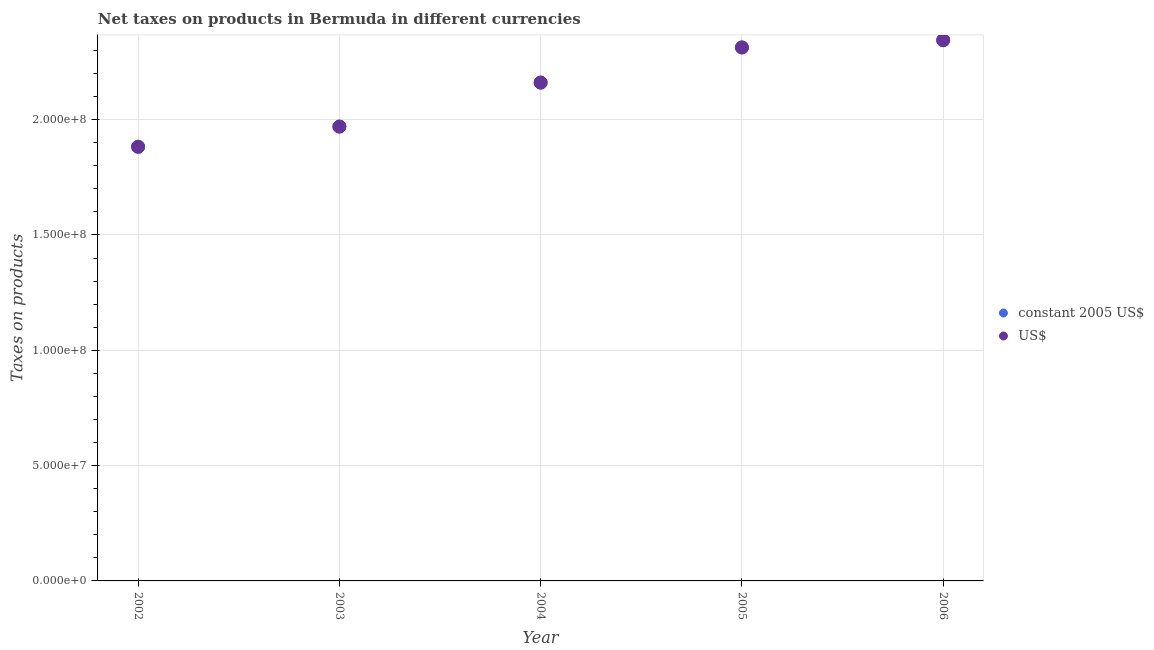What is the net taxes in us$ in 2005?
Your answer should be compact. 2.31e+08. Across all years, what is the maximum net taxes in us$?
Your response must be concise. 2.34e+08. Across all years, what is the minimum net taxes in us$?
Offer a very short reply. 1.88e+08. In which year was the net taxes in us$ maximum?
Provide a short and direct response. 2006. In which year was the net taxes in us$ minimum?
Offer a terse response. 2002. What is the total net taxes in constant 2005 us$ in the graph?
Keep it short and to the point. 1.07e+09. What is the difference between the net taxes in constant 2005 us$ in 2004 and that in 2006?
Keep it short and to the point. -1.84e+07. What is the difference between the net taxes in us$ in 2006 and the net taxes in constant 2005 us$ in 2005?
Make the answer very short. 3.14e+06. What is the average net taxes in us$ per year?
Provide a short and direct response. 2.13e+08. In the year 2005, what is the difference between the net taxes in constant 2005 us$ and net taxes in us$?
Provide a succinct answer. 0. In how many years, is the net taxes in us$ greater than 90000000 units?
Your answer should be compact. 5. What is the ratio of the net taxes in constant 2005 us$ in 2002 to that in 2006?
Keep it short and to the point. 0.8. Is the difference between the net taxes in constant 2005 us$ in 2005 and 2006 greater than the difference between the net taxes in us$ in 2005 and 2006?
Offer a terse response. No. What is the difference between the highest and the second highest net taxes in constant 2005 us$?
Give a very brief answer. 3.14e+06. What is the difference between the highest and the lowest net taxes in constant 2005 us$?
Keep it short and to the point. 4.62e+07. Is the sum of the net taxes in us$ in 2003 and 2006 greater than the maximum net taxes in constant 2005 us$ across all years?
Offer a very short reply. Yes. Does the net taxes in constant 2005 us$ monotonically increase over the years?
Your response must be concise. Yes. Is the net taxes in us$ strictly greater than the net taxes in constant 2005 us$ over the years?
Provide a succinct answer. No. Is the net taxes in us$ strictly less than the net taxes in constant 2005 us$ over the years?
Offer a very short reply. No. Does the graph contain any zero values?
Your answer should be compact. No. What is the title of the graph?
Make the answer very short. Net taxes on products in Bermuda in different currencies. What is the label or title of the Y-axis?
Your answer should be compact. Taxes on products. What is the Taxes on products in constant 2005 US$ in 2002?
Ensure brevity in your answer.  1.88e+08. What is the Taxes on products in US$ in 2002?
Ensure brevity in your answer.  1.88e+08. What is the Taxes on products of constant 2005 US$ in 2003?
Keep it short and to the point. 1.97e+08. What is the Taxes on products of US$ in 2003?
Your response must be concise. 1.97e+08. What is the Taxes on products of constant 2005 US$ in 2004?
Your answer should be compact. 2.16e+08. What is the Taxes on products of US$ in 2004?
Your answer should be compact. 2.16e+08. What is the Taxes on products of constant 2005 US$ in 2005?
Your response must be concise. 2.31e+08. What is the Taxes on products of US$ in 2005?
Give a very brief answer. 2.31e+08. What is the Taxes on products of constant 2005 US$ in 2006?
Ensure brevity in your answer.  2.34e+08. What is the Taxes on products in US$ in 2006?
Keep it short and to the point. 2.34e+08. Across all years, what is the maximum Taxes on products of constant 2005 US$?
Ensure brevity in your answer.  2.34e+08. Across all years, what is the maximum Taxes on products of US$?
Provide a short and direct response. 2.34e+08. Across all years, what is the minimum Taxes on products in constant 2005 US$?
Your response must be concise. 1.88e+08. Across all years, what is the minimum Taxes on products of US$?
Your response must be concise. 1.88e+08. What is the total Taxes on products of constant 2005 US$ in the graph?
Provide a short and direct response. 1.07e+09. What is the total Taxes on products of US$ in the graph?
Your answer should be compact. 1.07e+09. What is the difference between the Taxes on products of constant 2005 US$ in 2002 and that in 2003?
Give a very brief answer. -8.75e+06. What is the difference between the Taxes on products in US$ in 2002 and that in 2003?
Offer a terse response. -8.75e+06. What is the difference between the Taxes on products in constant 2005 US$ in 2002 and that in 2004?
Provide a short and direct response. -2.78e+07. What is the difference between the Taxes on products in US$ in 2002 and that in 2004?
Offer a very short reply. -2.78e+07. What is the difference between the Taxes on products in constant 2005 US$ in 2002 and that in 2005?
Offer a very short reply. -4.31e+07. What is the difference between the Taxes on products in US$ in 2002 and that in 2005?
Keep it short and to the point. -4.31e+07. What is the difference between the Taxes on products in constant 2005 US$ in 2002 and that in 2006?
Offer a very short reply. -4.62e+07. What is the difference between the Taxes on products in US$ in 2002 and that in 2006?
Offer a very short reply. -4.62e+07. What is the difference between the Taxes on products in constant 2005 US$ in 2003 and that in 2004?
Offer a terse response. -1.91e+07. What is the difference between the Taxes on products of US$ in 2003 and that in 2004?
Offer a terse response. -1.91e+07. What is the difference between the Taxes on products in constant 2005 US$ in 2003 and that in 2005?
Provide a succinct answer. -3.43e+07. What is the difference between the Taxes on products of US$ in 2003 and that in 2005?
Provide a succinct answer. -3.43e+07. What is the difference between the Taxes on products in constant 2005 US$ in 2003 and that in 2006?
Offer a very short reply. -3.74e+07. What is the difference between the Taxes on products of US$ in 2003 and that in 2006?
Offer a terse response. -3.74e+07. What is the difference between the Taxes on products of constant 2005 US$ in 2004 and that in 2005?
Offer a very short reply. -1.52e+07. What is the difference between the Taxes on products in US$ in 2004 and that in 2005?
Offer a terse response. -1.52e+07. What is the difference between the Taxes on products in constant 2005 US$ in 2004 and that in 2006?
Offer a very short reply. -1.84e+07. What is the difference between the Taxes on products in US$ in 2004 and that in 2006?
Offer a terse response. -1.84e+07. What is the difference between the Taxes on products in constant 2005 US$ in 2005 and that in 2006?
Provide a succinct answer. -3.14e+06. What is the difference between the Taxes on products in US$ in 2005 and that in 2006?
Ensure brevity in your answer.  -3.14e+06. What is the difference between the Taxes on products in constant 2005 US$ in 2002 and the Taxes on products in US$ in 2003?
Your response must be concise. -8.75e+06. What is the difference between the Taxes on products of constant 2005 US$ in 2002 and the Taxes on products of US$ in 2004?
Provide a succinct answer. -2.78e+07. What is the difference between the Taxes on products of constant 2005 US$ in 2002 and the Taxes on products of US$ in 2005?
Make the answer very short. -4.31e+07. What is the difference between the Taxes on products in constant 2005 US$ in 2002 and the Taxes on products in US$ in 2006?
Give a very brief answer. -4.62e+07. What is the difference between the Taxes on products in constant 2005 US$ in 2003 and the Taxes on products in US$ in 2004?
Give a very brief answer. -1.91e+07. What is the difference between the Taxes on products of constant 2005 US$ in 2003 and the Taxes on products of US$ in 2005?
Your response must be concise. -3.43e+07. What is the difference between the Taxes on products in constant 2005 US$ in 2003 and the Taxes on products in US$ in 2006?
Your response must be concise. -3.74e+07. What is the difference between the Taxes on products in constant 2005 US$ in 2004 and the Taxes on products in US$ in 2005?
Make the answer very short. -1.52e+07. What is the difference between the Taxes on products of constant 2005 US$ in 2004 and the Taxes on products of US$ in 2006?
Offer a very short reply. -1.84e+07. What is the difference between the Taxes on products of constant 2005 US$ in 2005 and the Taxes on products of US$ in 2006?
Offer a very short reply. -3.14e+06. What is the average Taxes on products of constant 2005 US$ per year?
Make the answer very short. 2.13e+08. What is the average Taxes on products of US$ per year?
Your response must be concise. 2.13e+08. In the year 2002, what is the difference between the Taxes on products of constant 2005 US$ and Taxes on products of US$?
Ensure brevity in your answer.  0. In the year 2005, what is the difference between the Taxes on products of constant 2005 US$ and Taxes on products of US$?
Offer a terse response. 0. In the year 2006, what is the difference between the Taxes on products in constant 2005 US$ and Taxes on products in US$?
Provide a succinct answer. 0. What is the ratio of the Taxes on products of constant 2005 US$ in 2002 to that in 2003?
Your answer should be very brief. 0.96. What is the ratio of the Taxes on products in US$ in 2002 to that in 2003?
Your answer should be very brief. 0.96. What is the ratio of the Taxes on products of constant 2005 US$ in 2002 to that in 2004?
Offer a terse response. 0.87. What is the ratio of the Taxes on products in US$ in 2002 to that in 2004?
Make the answer very short. 0.87. What is the ratio of the Taxes on products of constant 2005 US$ in 2002 to that in 2005?
Ensure brevity in your answer.  0.81. What is the ratio of the Taxes on products of US$ in 2002 to that in 2005?
Ensure brevity in your answer.  0.81. What is the ratio of the Taxes on products of constant 2005 US$ in 2002 to that in 2006?
Ensure brevity in your answer.  0.8. What is the ratio of the Taxes on products in US$ in 2002 to that in 2006?
Keep it short and to the point. 0.8. What is the ratio of the Taxes on products in constant 2005 US$ in 2003 to that in 2004?
Your answer should be very brief. 0.91. What is the ratio of the Taxes on products of US$ in 2003 to that in 2004?
Ensure brevity in your answer.  0.91. What is the ratio of the Taxes on products of constant 2005 US$ in 2003 to that in 2005?
Your answer should be very brief. 0.85. What is the ratio of the Taxes on products in US$ in 2003 to that in 2005?
Provide a short and direct response. 0.85. What is the ratio of the Taxes on products in constant 2005 US$ in 2003 to that in 2006?
Your answer should be compact. 0.84. What is the ratio of the Taxes on products of US$ in 2003 to that in 2006?
Provide a succinct answer. 0.84. What is the ratio of the Taxes on products of constant 2005 US$ in 2004 to that in 2005?
Offer a terse response. 0.93. What is the ratio of the Taxes on products of US$ in 2004 to that in 2005?
Offer a very short reply. 0.93. What is the ratio of the Taxes on products of constant 2005 US$ in 2004 to that in 2006?
Keep it short and to the point. 0.92. What is the ratio of the Taxes on products in US$ in 2004 to that in 2006?
Offer a very short reply. 0.92. What is the ratio of the Taxes on products in constant 2005 US$ in 2005 to that in 2006?
Your answer should be very brief. 0.99. What is the ratio of the Taxes on products in US$ in 2005 to that in 2006?
Ensure brevity in your answer.  0.99. What is the difference between the highest and the second highest Taxes on products in constant 2005 US$?
Ensure brevity in your answer.  3.14e+06. What is the difference between the highest and the second highest Taxes on products of US$?
Provide a short and direct response. 3.14e+06. What is the difference between the highest and the lowest Taxes on products of constant 2005 US$?
Your answer should be compact. 4.62e+07. What is the difference between the highest and the lowest Taxes on products of US$?
Your response must be concise. 4.62e+07. 